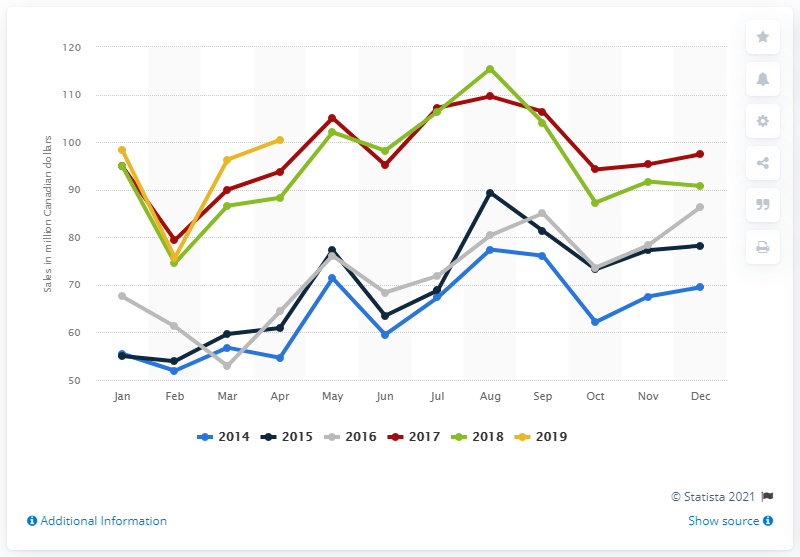Outline some significant characteristics in this image. In April 2019, the retail sales of mattresses and foundations at large retailers in Canada were $100.46 million. 